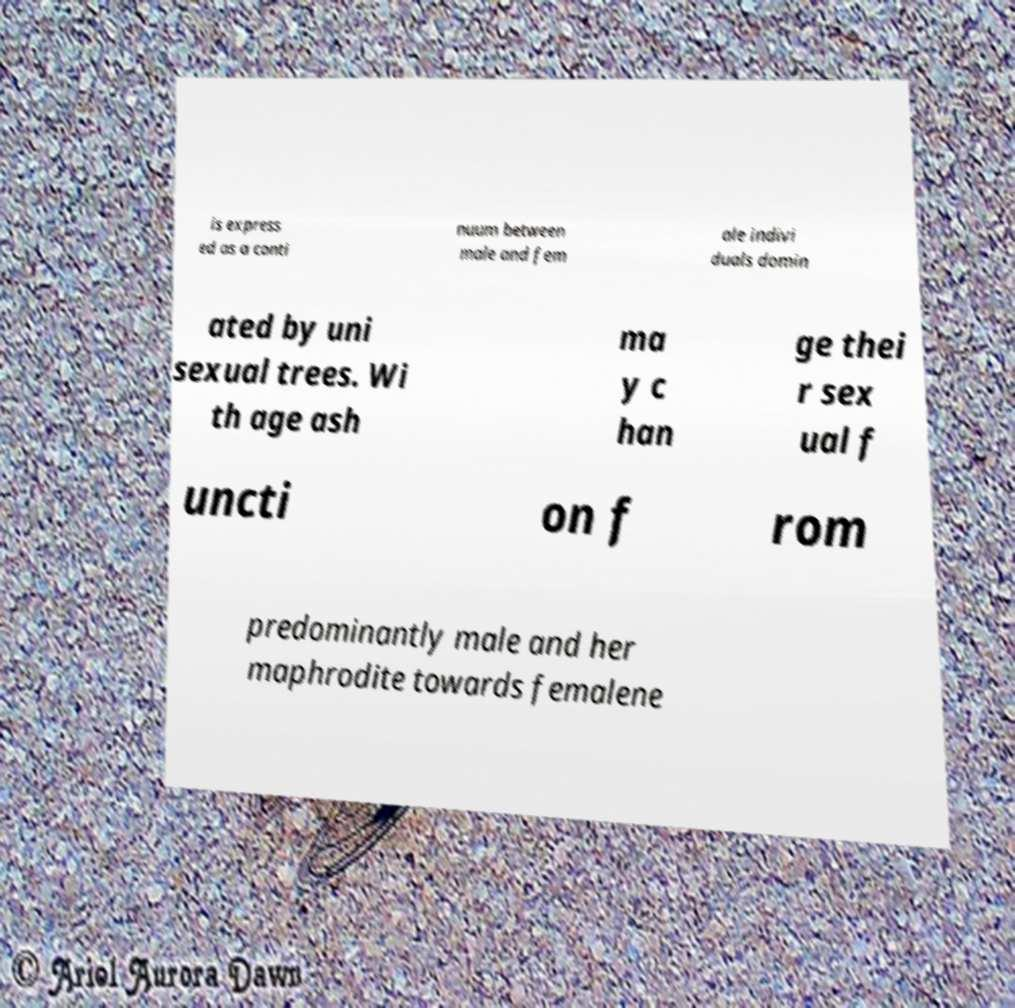I need the written content from this picture converted into text. Can you do that? is express ed as a conti nuum between male and fem ale indivi duals domin ated by uni sexual trees. Wi th age ash ma y c han ge thei r sex ual f uncti on f rom predominantly male and her maphrodite towards femalene 